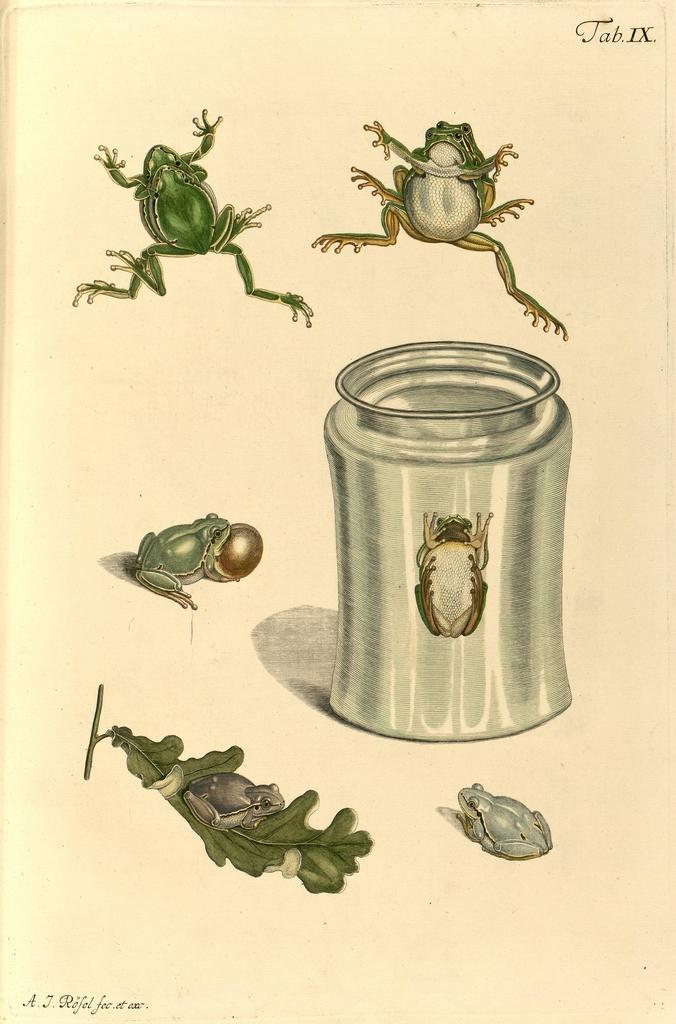How would you summarize this image in a sentence or two? This image consists of a paper on which I can see few paintings of frogs, a leaf and a jar. Inside the jar there is an insect. 